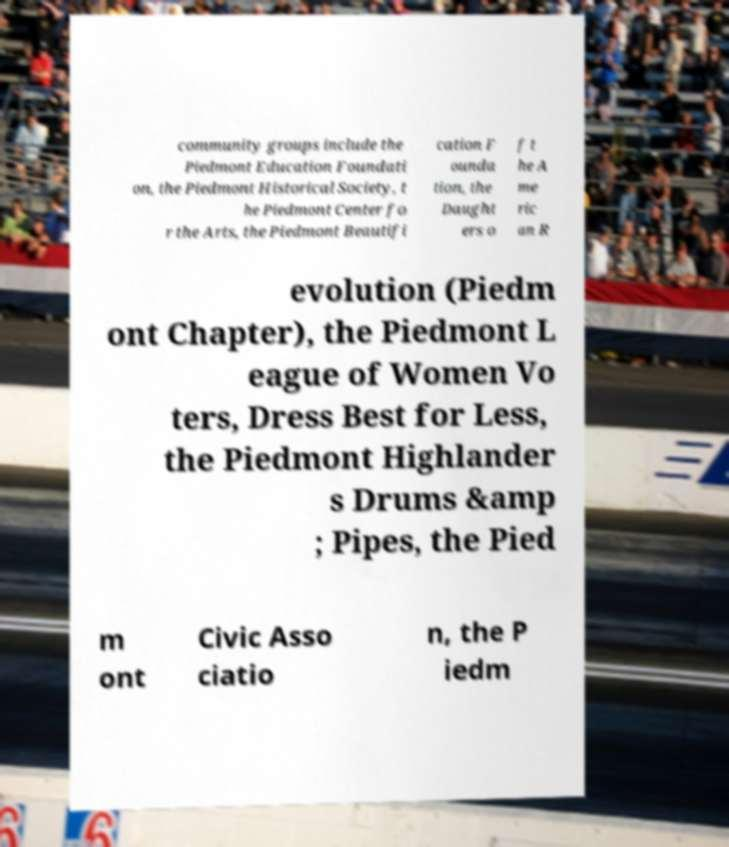There's text embedded in this image that I need extracted. Can you transcribe it verbatim? community groups include the Piedmont Education Foundati on, the Piedmont Historical Society, t he Piedmont Center fo r the Arts, the Piedmont Beautifi cation F ounda tion, the Daught ers o f t he A me ric an R evolution (Piedm ont Chapter), the Piedmont L eague of Women Vo ters, Dress Best for Less, the Piedmont Highlander s Drums &amp ; Pipes, the Pied m ont Civic Asso ciatio n, the P iedm 